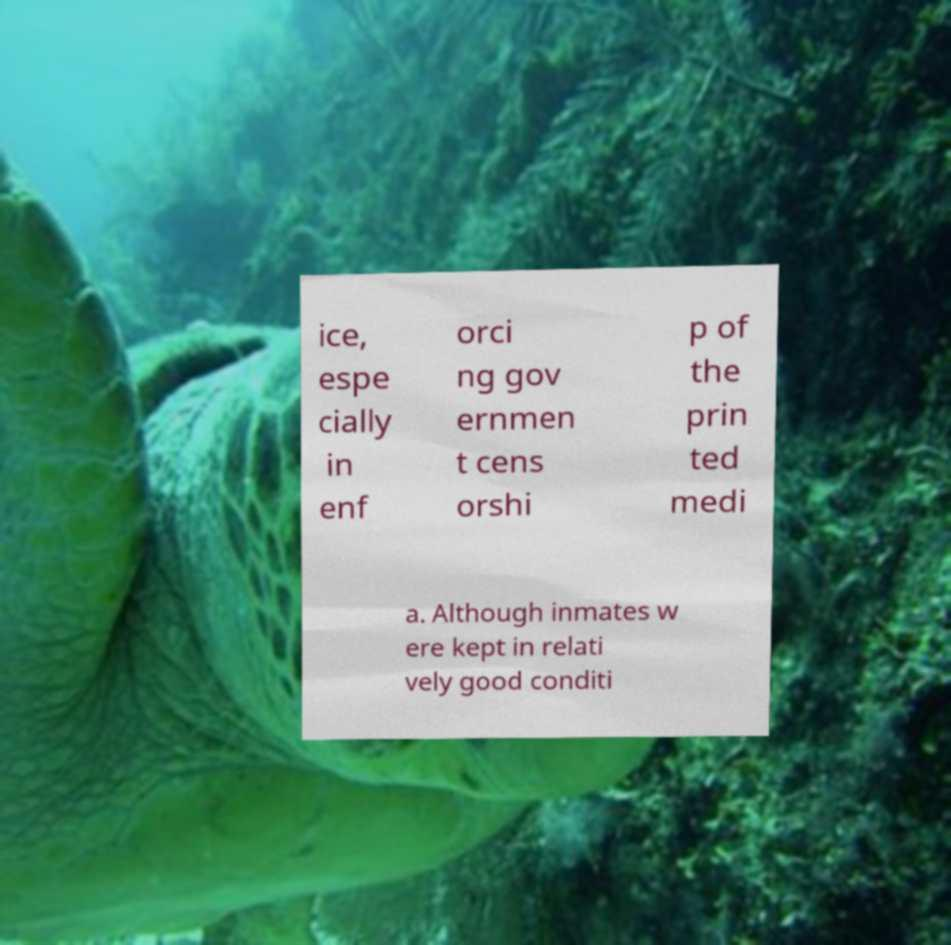Could you extract and type out the text from this image? ice, espe cially in enf orci ng gov ernmen t cens orshi p of the prin ted medi a. Although inmates w ere kept in relati vely good conditi 